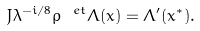Convert formula to latex. <formula><loc_0><loc_0><loc_500><loc_500>J \lambda ^ { - i / 8 } \rho ^ { \ e t } \Lambda ( x ) = \Lambda ^ { \prime } ( x ^ { * } ) .</formula> 